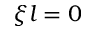<formula> <loc_0><loc_0><loc_500><loc_500>\xi l = 0</formula> 